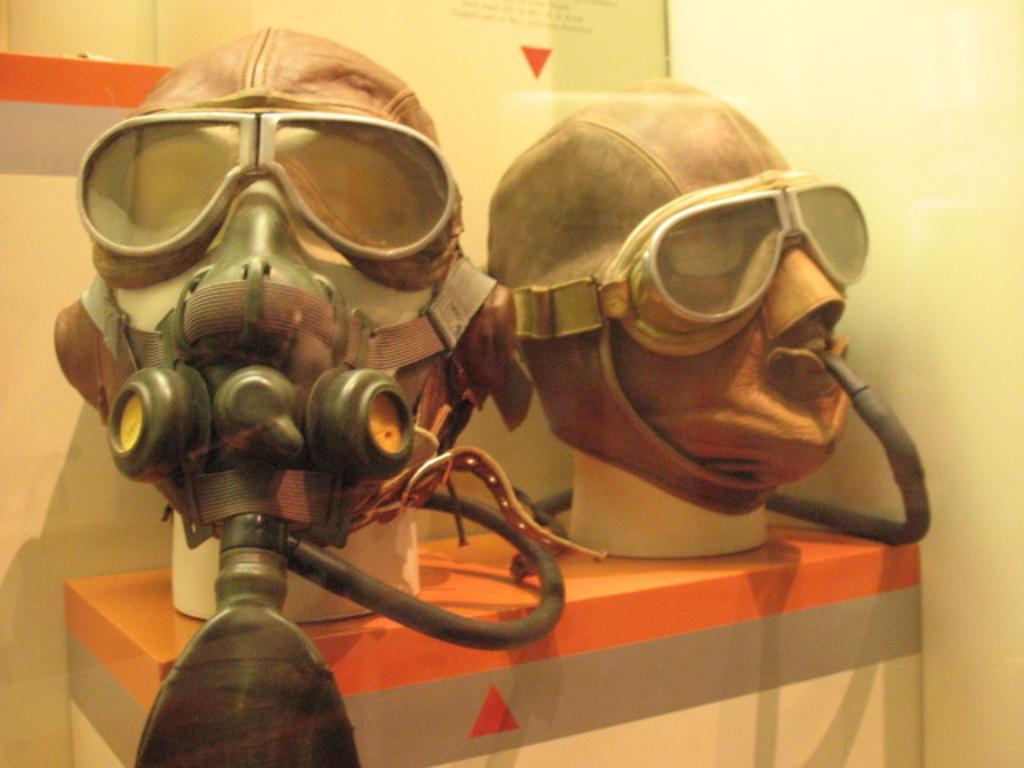How would you summarize this image in a sentence or two? This is the picture of gas mask with cylinder on the table in the foreground. And there is a wall in the background 